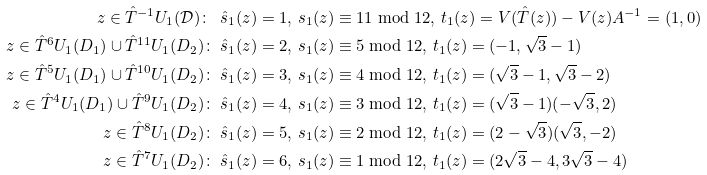<formula> <loc_0><loc_0><loc_500><loc_500>z \in \hat { T } ^ { - 1 } U _ { 1 } ( \mathcal { D } ) \colon \ & \hat { s } _ { 1 } ( z ) = 1 , \, s _ { 1 } ( z ) \equiv 1 1 \bmod 1 2 , \, t _ { 1 } ( z ) = V ( \hat { T } ( z ) ) - V ( z ) A ^ { - 1 } = ( 1 , 0 ) \\ z \in \hat { T } ^ { 6 } U _ { 1 } ( D _ { 1 } ) \cup \hat { T } ^ { 1 1 } U _ { 1 } ( D _ { 2 } ) \colon \ & \hat { s } _ { 1 } ( z ) = 2 , \, s _ { 1 } ( z ) \equiv 5 \bmod 1 2 , \, t _ { 1 } ( z ) = ( - 1 , \sqrt { 3 } - 1 ) \\ z \in \hat { T } ^ { 5 } U _ { 1 } ( D _ { 1 } ) \cup \hat { T } ^ { 1 0 } U _ { 1 } ( D _ { 2 } ) \colon \ & \hat { s } _ { 1 } ( z ) = 3 , \, s _ { 1 } ( z ) \equiv 4 \bmod 1 2 , \, t _ { 1 } ( z ) = ( \sqrt { 3 } - 1 , \sqrt { 3 } - 2 ) \\ z \in \hat { T } ^ { 4 } U _ { 1 } ( D _ { 1 } ) \cup \hat { T } ^ { 9 } U _ { 1 } ( D _ { 2 } ) \colon \ & \hat { s } _ { 1 } ( z ) = 4 , \, s _ { 1 } ( z ) \equiv 3 \bmod 1 2 , \, t _ { 1 } ( z ) = ( \sqrt { 3 } - 1 ) ( - \sqrt { 3 } , 2 ) \\ z \in \hat { T } ^ { 8 } U _ { 1 } ( D _ { 2 } ) \colon \ & \hat { s } _ { 1 } ( z ) = 5 , \, s _ { 1 } ( z ) \equiv 2 \bmod 1 2 , \, t _ { 1 } ( z ) = ( 2 - \sqrt { 3 } ) ( \sqrt { 3 } , - 2 ) \\ z \in \hat { T } ^ { 7 } U _ { 1 } ( D _ { 2 } ) \colon \ & \hat { s } _ { 1 } ( z ) = 6 , \, s _ { 1 } ( z ) \equiv 1 \bmod 1 2 , \, t _ { 1 } ( z ) = ( 2 \sqrt { 3 } - 4 , 3 \sqrt { 3 } - 4 )</formula> 